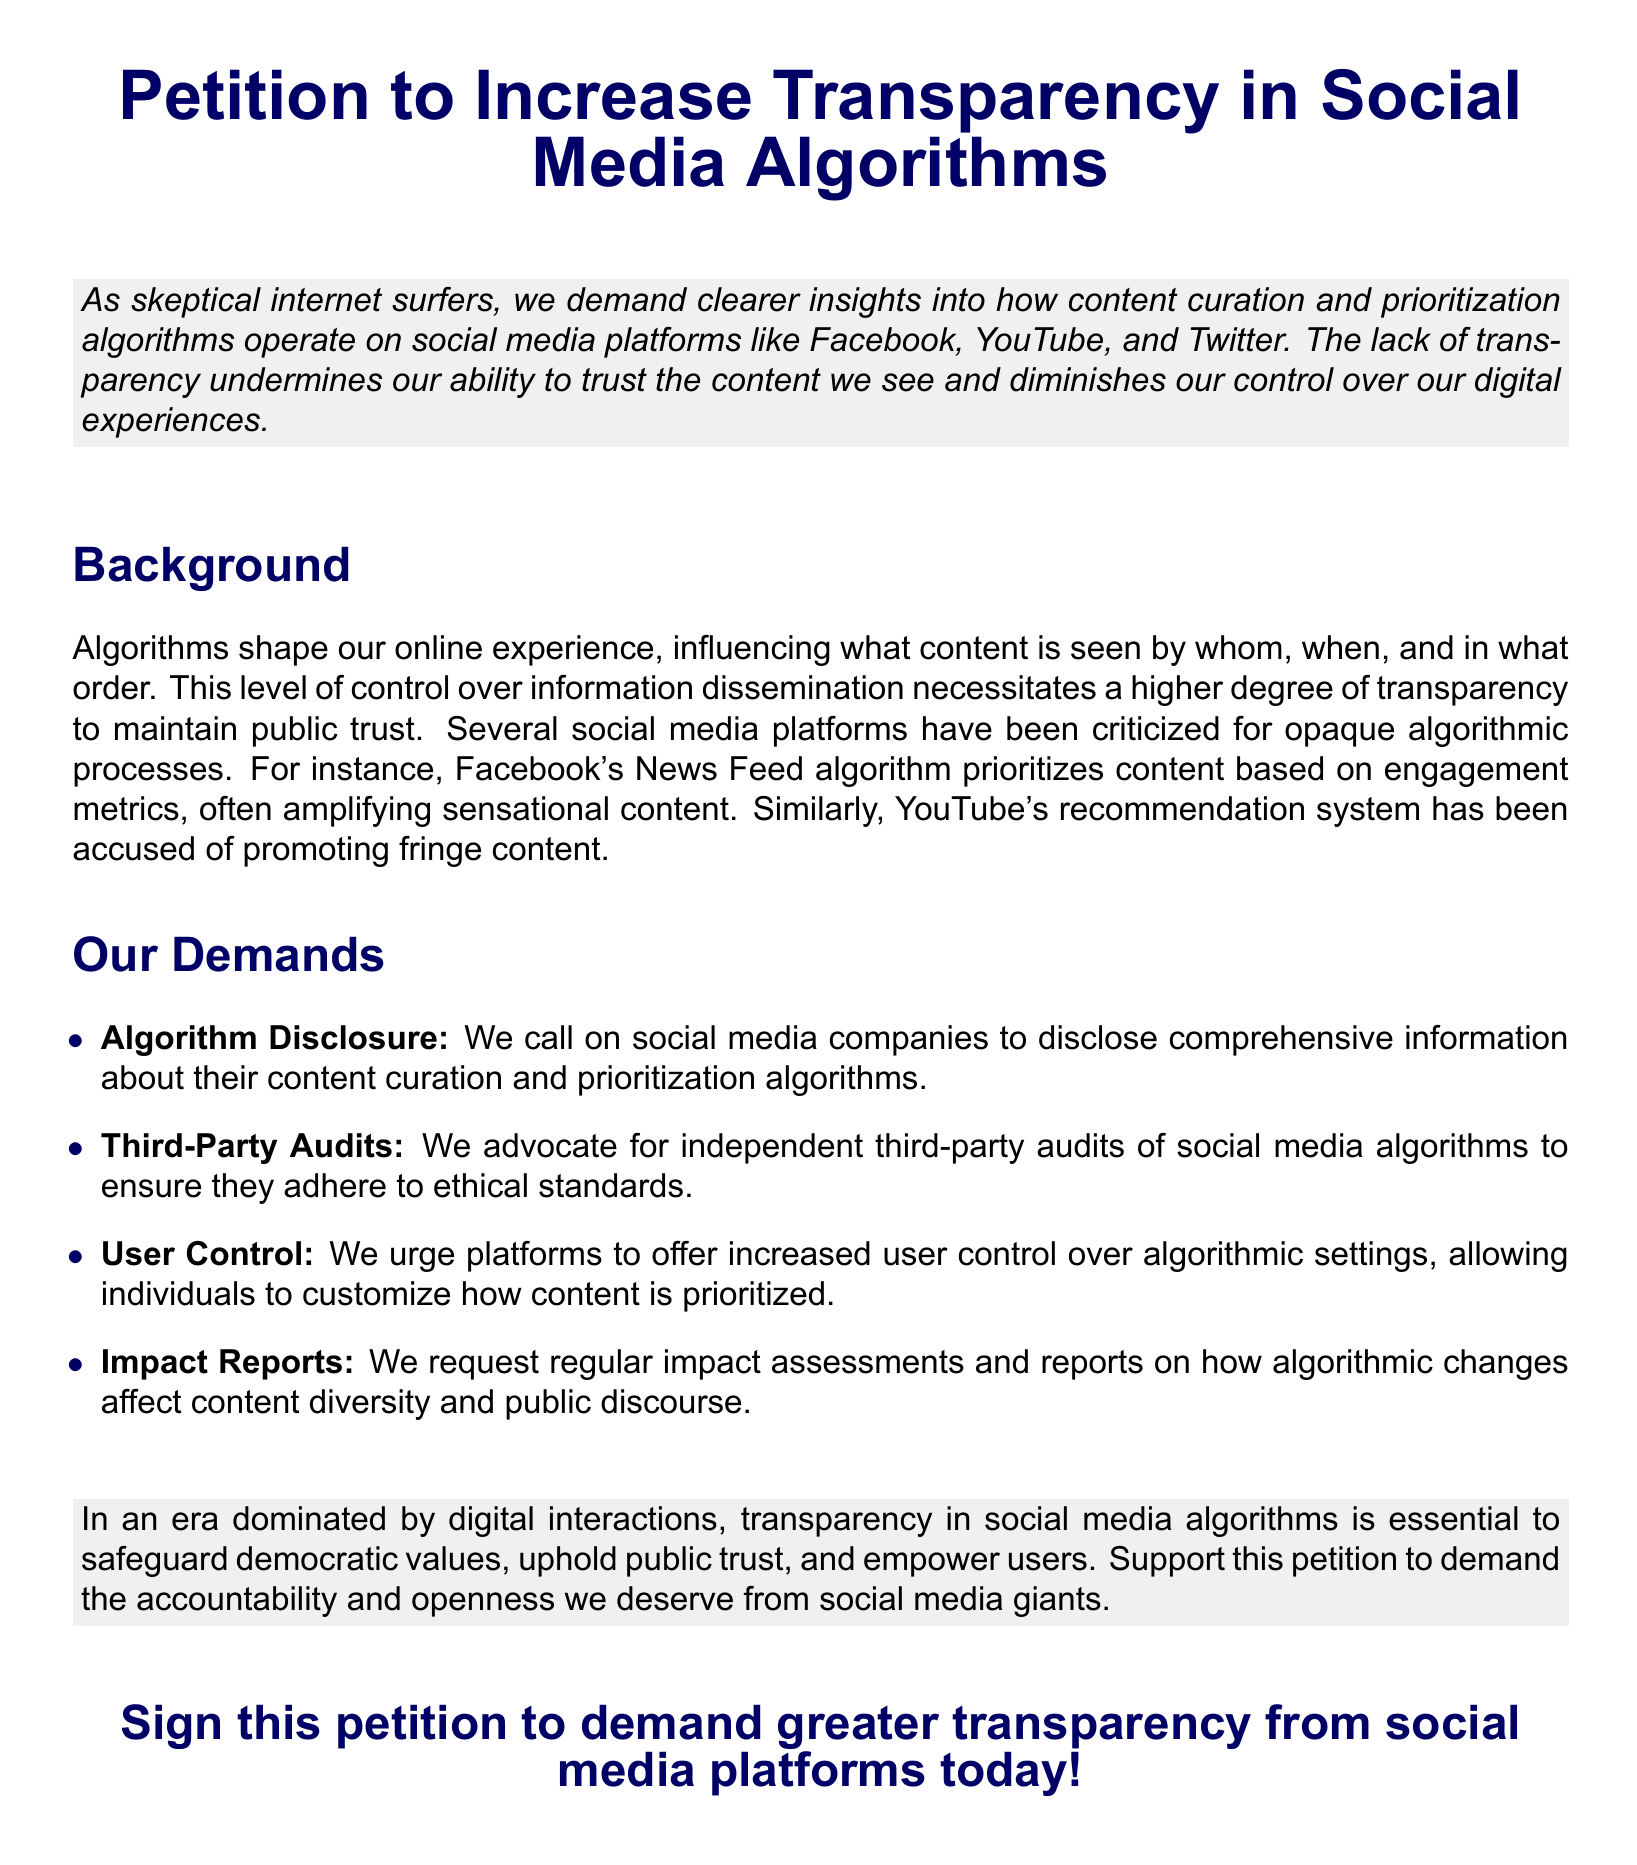What is the main purpose of the petition? The main purpose of the petition is to demand clearer insights into social media algorithms and foster transparency.
Answer: Increase transparency in social media algorithms Which social media platforms are mentioned in the petition? The petition specifically mentions Facebook, YouTube, and Twitter as platforms of concern.
Answer: Facebook, YouTube, and Twitter What is one of the demands of the petition regarding algorithm audits? The petition demands independent third-party audits of social media algorithms.
Answer: Third-party audits What type of reports does the petition request regarding algorithm changes? The petition requests regular impact assessments and reports on algorithmic changes and their effects.
Answer: Impact reports What color is used for the title of the petition? The color used for the title of the petition is dark blue.
Answer: Dark blue What is highlighted as undermining user trust? The lack of transparency in how content is curated and prioritized is highlighted as undermining trust.
Answer: Lack of transparency What do social media companies need to disclose according to the petition? Social media companies need to disclose comprehensive information about their content curation and prioritization algorithms.
Answer: Algorithm disclosure How many key demands are listed in the petition? The petition lists four key demands concerning social media algorithm transparency.
Answer: Four 